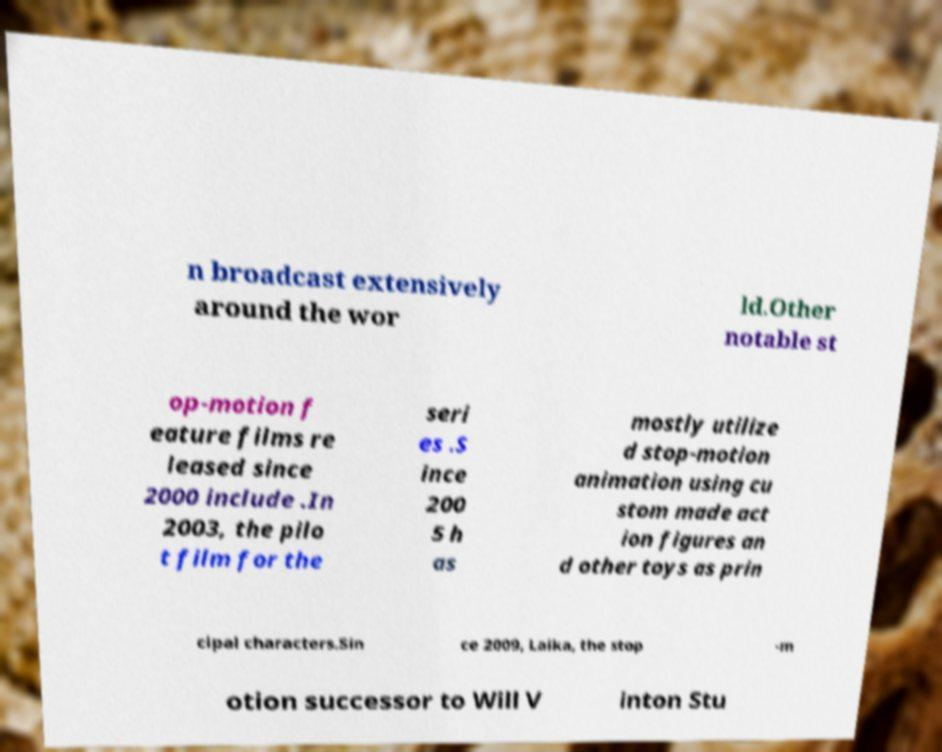Could you extract and type out the text from this image? n broadcast extensively around the wor ld.Other notable st op-motion f eature films re leased since 2000 include .In 2003, the pilo t film for the seri es .S ince 200 5 h as mostly utilize d stop-motion animation using cu stom made act ion figures an d other toys as prin cipal characters.Sin ce 2009, Laika, the stop -m otion successor to Will V inton Stu 